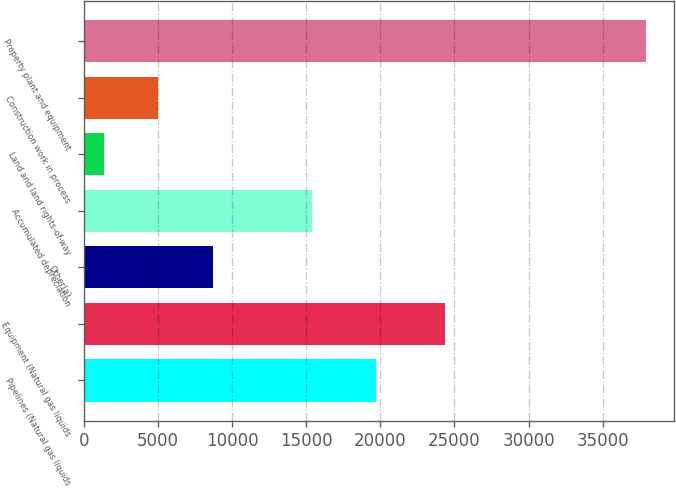Convert chart. <chart><loc_0><loc_0><loc_500><loc_500><bar_chart><fcel>Pipelines (Natural gas liquids<fcel>Equipment (Natural gas liquids<fcel>Other(a)<fcel>Accumulated depreciation<fcel>Land and land rights-of-way<fcel>Construction work in process<fcel>Property plant and equipment<nl><fcel>19727<fcel>24392<fcel>8681.8<fcel>15359<fcel>1378<fcel>5029.9<fcel>37897<nl></chart> 